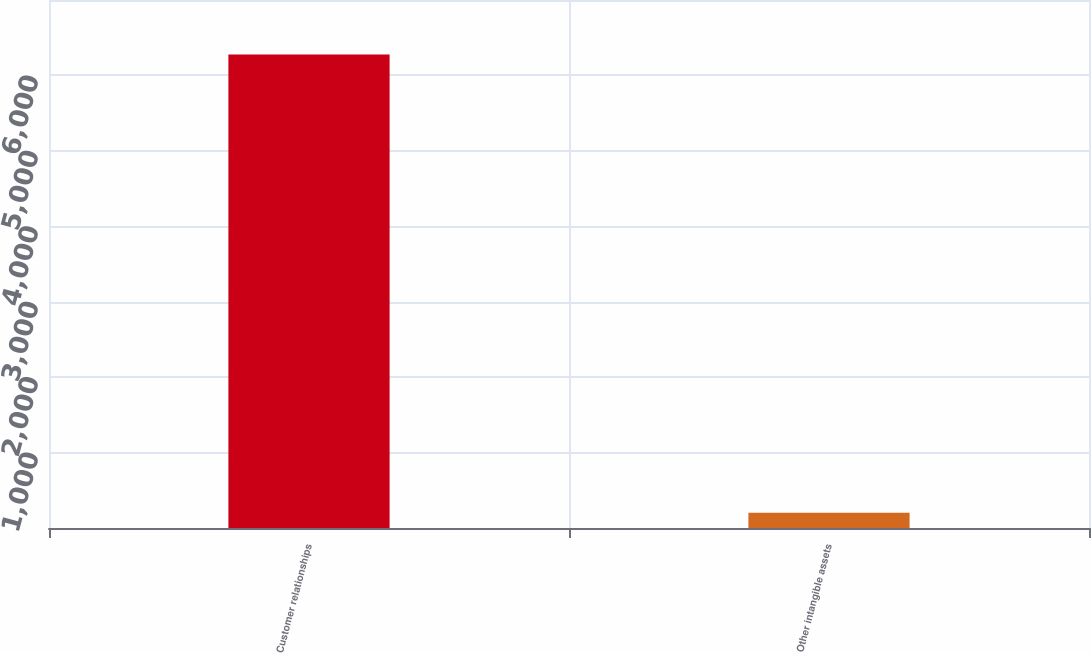Convert chart. <chart><loc_0><loc_0><loc_500><loc_500><bar_chart><fcel>Customer relationships<fcel>Other intangible assets<nl><fcel>6278<fcel>201<nl></chart> 